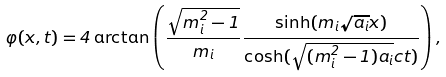<formula> <loc_0><loc_0><loc_500><loc_500>\varphi ( x , t ) = 4 \arctan \left ( \frac { \sqrt { m ^ { 2 } _ { i } - 1 } } { m _ { i } } \frac { \sinh ( m _ { i } \sqrt { a _ { i } } x ) } { \cosh ( \sqrt { ( m ^ { 2 } _ { i } - 1 ) a _ { i } } c t ) } \right ) ,</formula> 